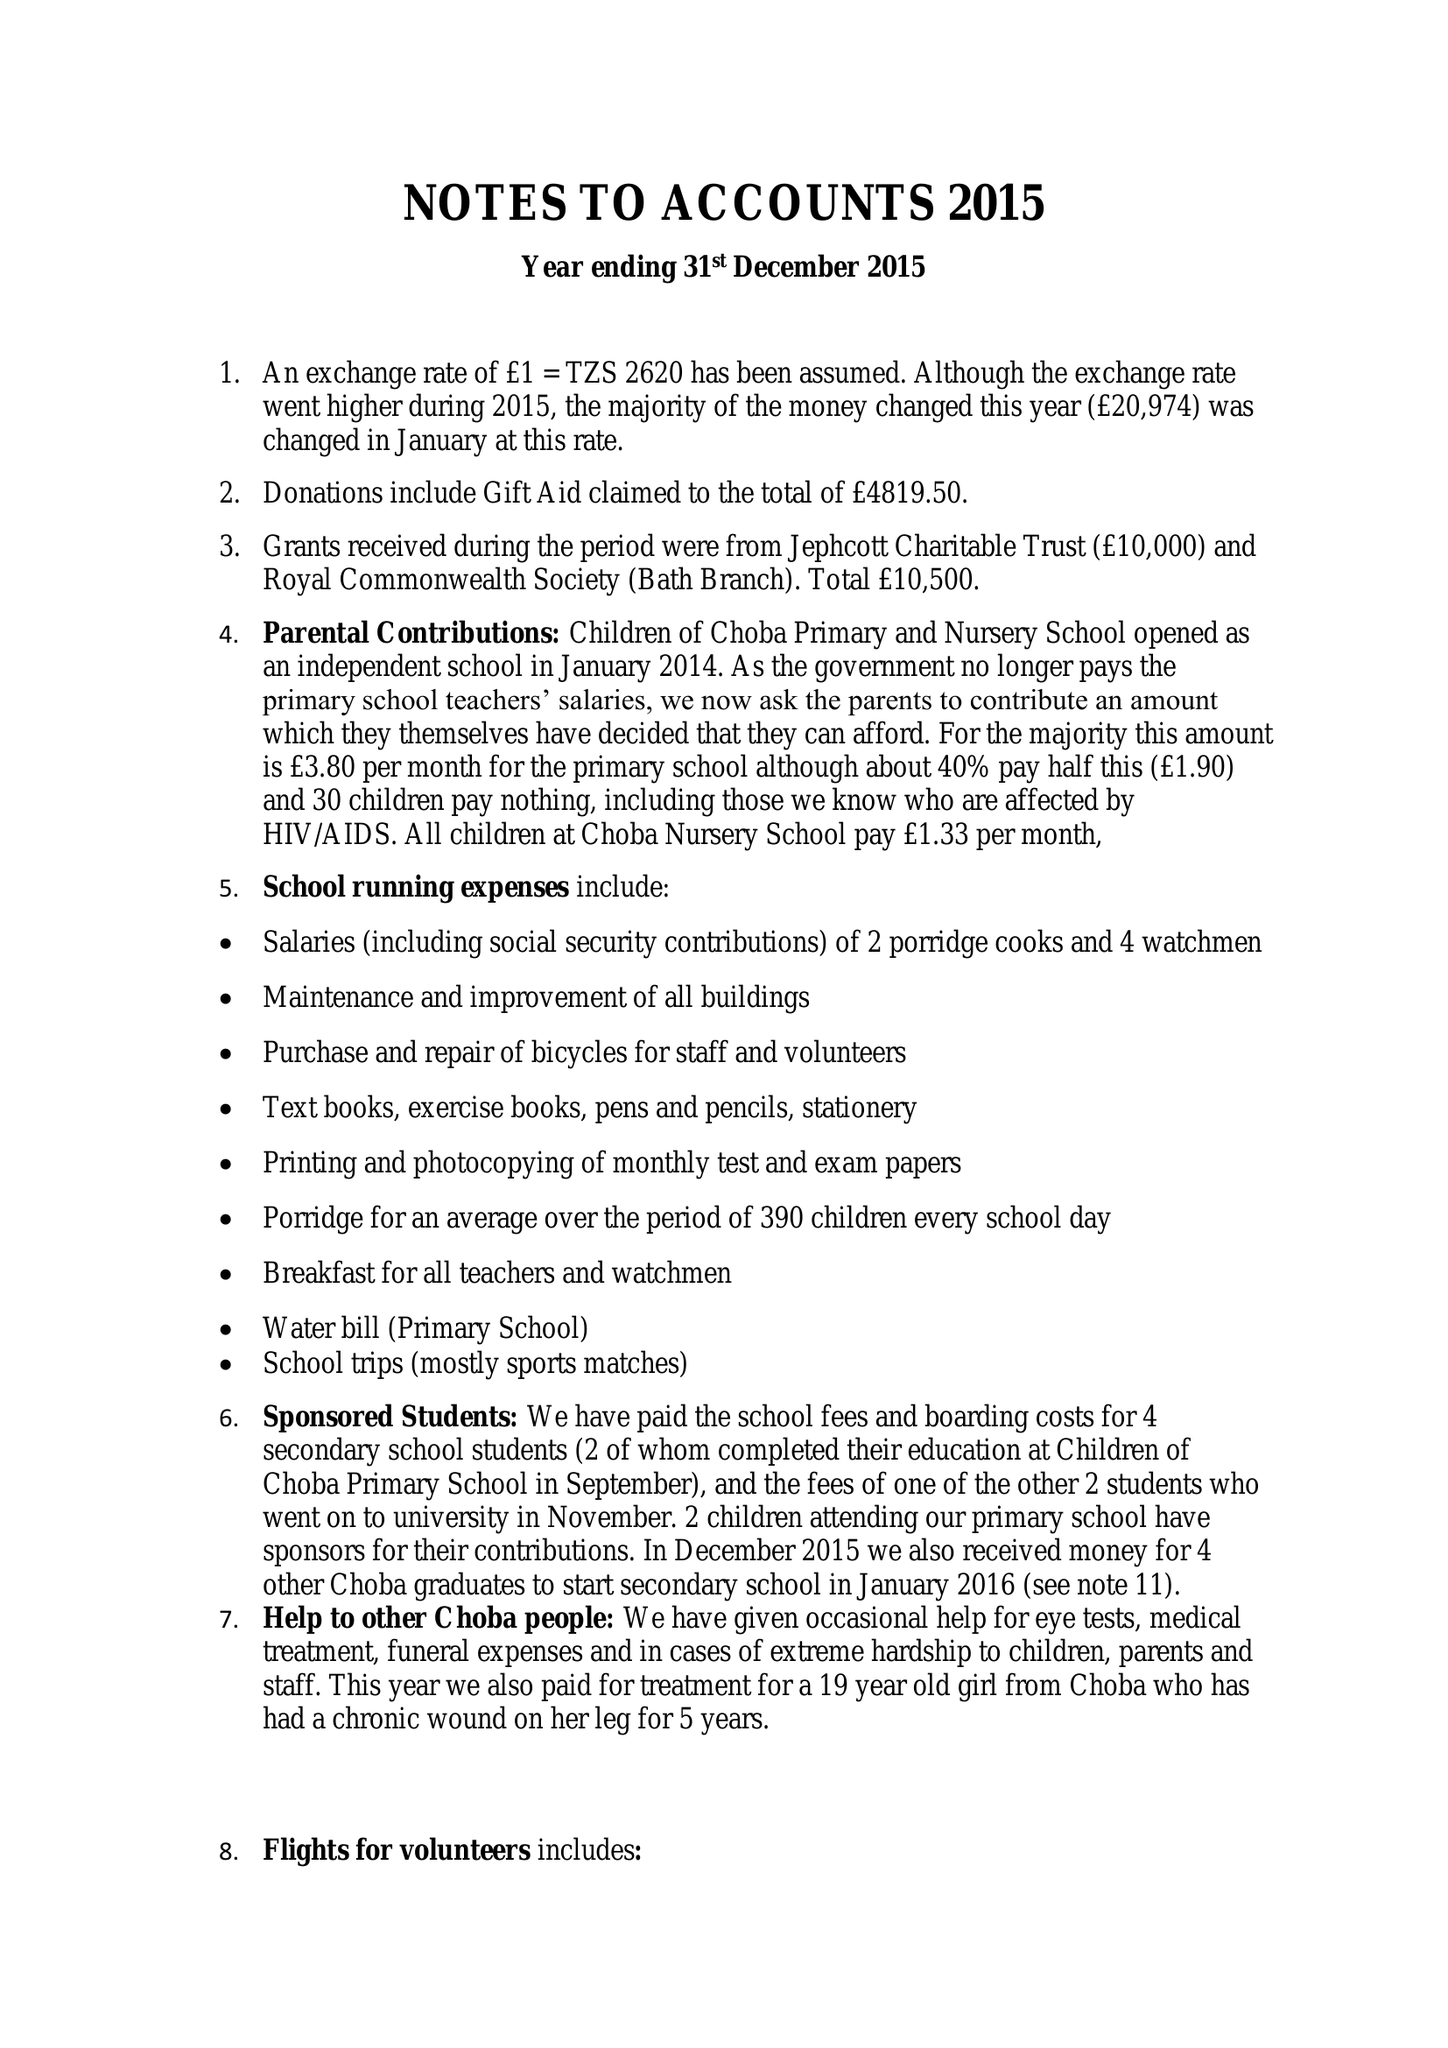What is the value for the address__post_town?
Answer the question using a single word or phrase. BATH 